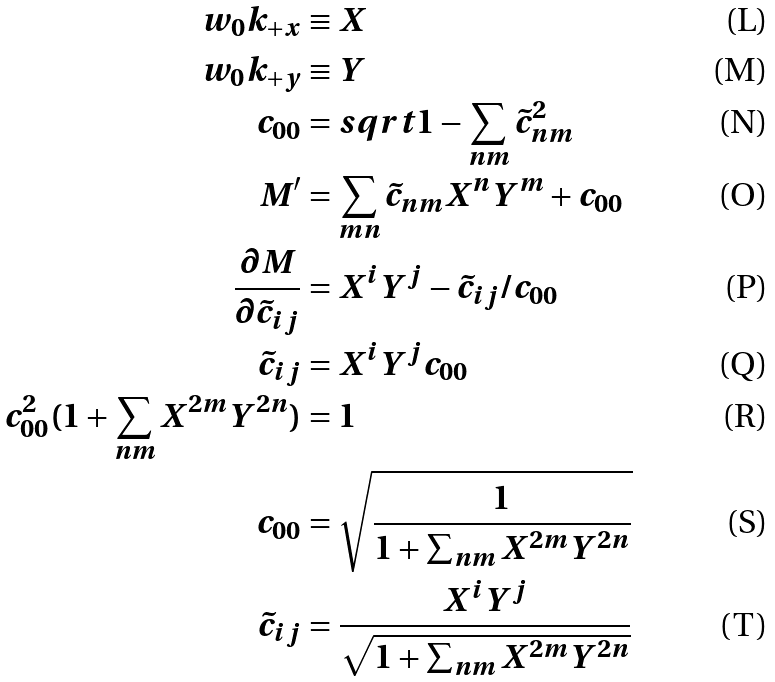<formula> <loc_0><loc_0><loc_500><loc_500>w _ { 0 } k _ { + x } & \equiv X \\ w _ { 0 } k _ { + y } & \equiv Y \\ c _ { 0 0 } & = s q r t { 1 - \sum _ { n m } \tilde { c } _ { n m } ^ { 2 } } \\ M ^ { \prime } & = \sum _ { m n } { \tilde { c } _ { n m } X ^ { n } Y ^ { m } + c _ { 0 0 } } \\ \frac { \partial M } { \partial \tilde { c } _ { i j } } & = X ^ { i } Y ^ { j } - \tilde { c } _ { i j } / c _ { 0 0 } \\ \tilde { c } _ { i j } & = X ^ { i } Y ^ { j } c _ { 0 0 } \\ c _ { 0 0 } ^ { 2 } ( 1 + \sum _ { n m } X ^ { 2 m } Y ^ { 2 n } ) & = 1 \\ c _ { 0 0 } & = \sqrt { \frac { 1 } { 1 + \sum _ { n m } X ^ { 2 m } Y ^ { 2 n } } } \\ \tilde { c } _ { i j } & = \frac { X ^ { i } Y ^ { j } } { \sqrt { 1 + \sum _ { n m } X ^ { 2 m } Y ^ { 2 n } } }</formula> 